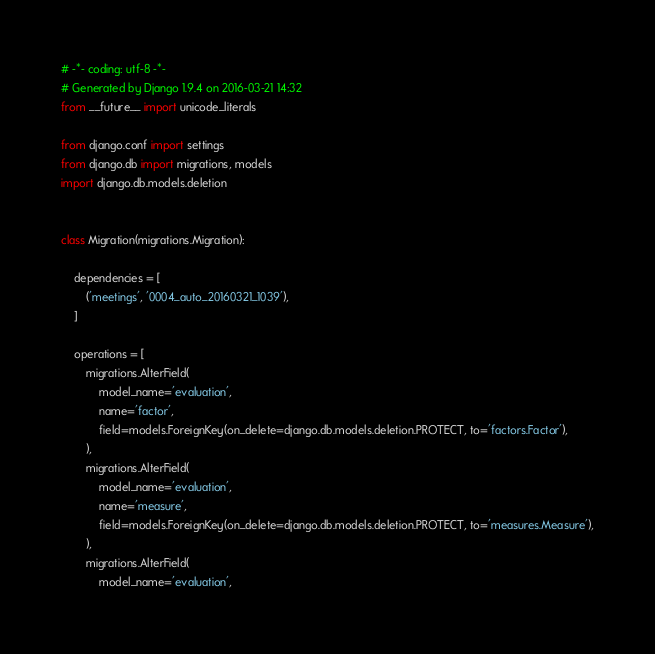<code> <loc_0><loc_0><loc_500><loc_500><_Python_># -*- coding: utf-8 -*-
# Generated by Django 1.9.4 on 2016-03-21 14:32
from __future__ import unicode_literals

from django.conf import settings
from django.db import migrations, models
import django.db.models.deletion


class Migration(migrations.Migration):

    dependencies = [
        ('meetings', '0004_auto_20160321_1039'),
    ]

    operations = [
        migrations.AlterField(
            model_name='evaluation',
            name='factor',
            field=models.ForeignKey(on_delete=django.db.models.deletion.PROTECT, to='factors.Factor'),
        ),
        migrations.AlterField(
            model_name='evaluation',
            name='measure',
            field=models.ForeignKey(on_delete=django.db.models.deletion.PROTECT, to='measures.Measure'),
        ),
        migrations.AlterField(
            model_name='evaluation',</code> 